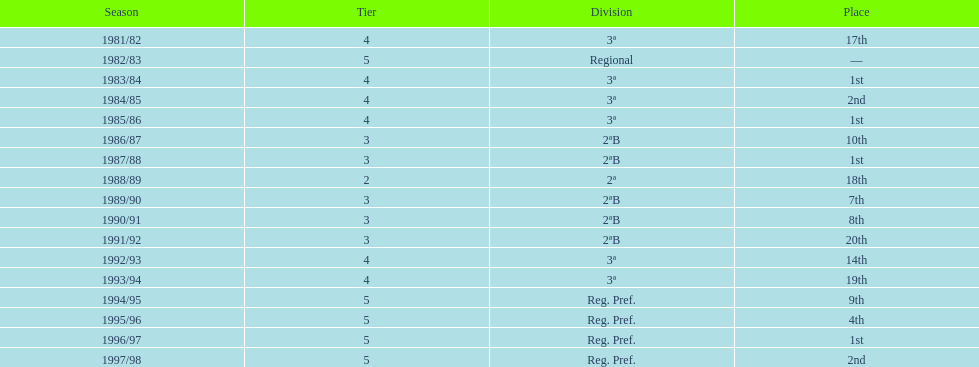In which year did the team have its worst season? 1991/92. 